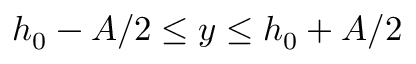Convert formula to latex. <formula><loc_0><loc_0><loc_500><loc_500>h _ { 0 } - A / 2 \leq y \leq h _ { 0 } + A / 2</formula> 